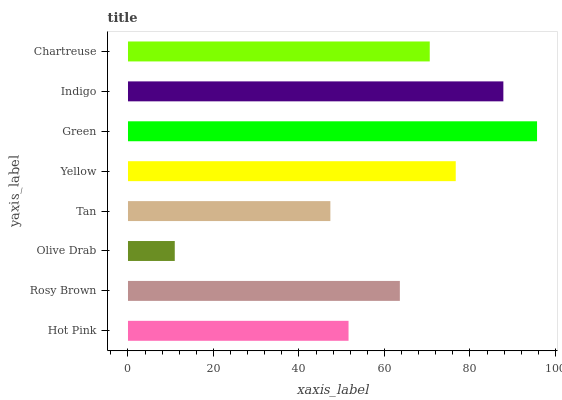Is Olive Drab the minimum?
Answer yes or no. Yes. Is Green the maximum?
Answer yes or no. Yes. Is Rosy Brown the minimum?
Answer yes or no. No. Is Rosy Brown the maximum?
Answer yes or no. No. Is Rosy Brown greater than Hot Pink?
Answer yes or no. Yes. Is Hot Pink less than Rosy Brown?
Answer yes or no. Yes. Is Hot Pink greater than Rosy Brown?
Answer yes or no. No. Is Rosy Brown less than Hot Pink?
Answer yes or no. No. Is Chartreuse the high median?
Answer yes or no. Yes. Is Rosy Brown the low median?
Answer yes or no. Yes. Is Green the high median?
Answer yes or no. No. Is Hot Pink the low median?
Answer yes or no. No. 